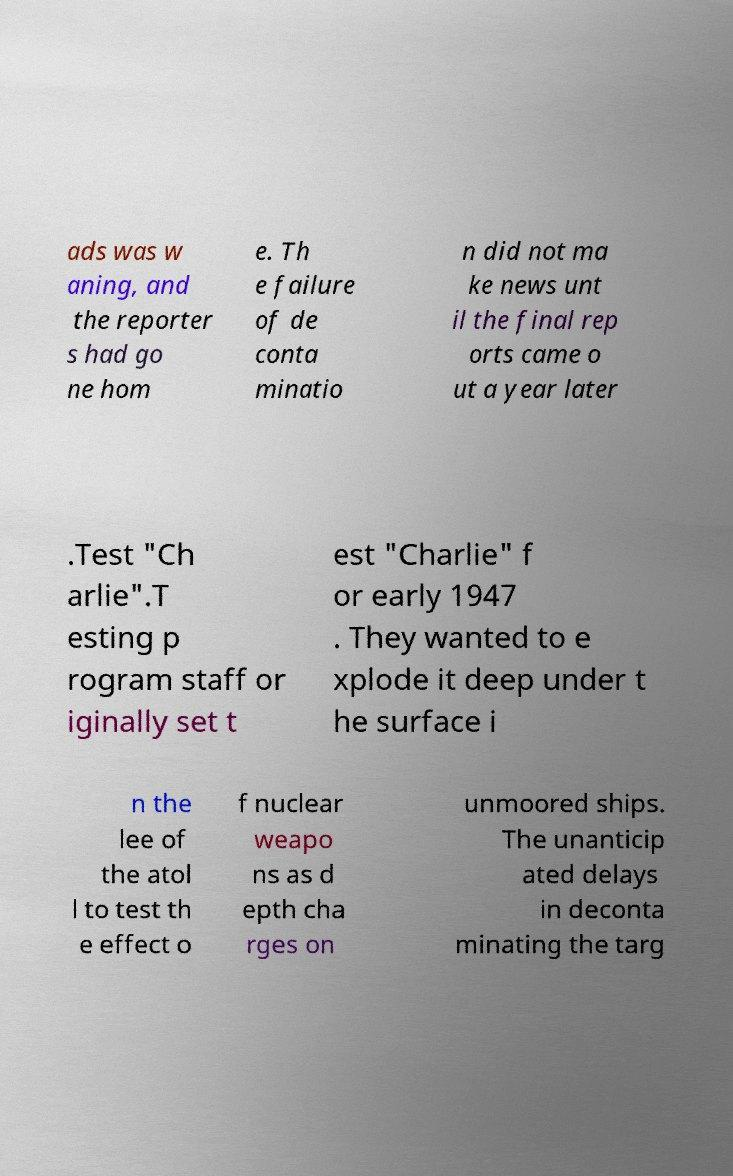I need the written content from this picture converted into text. Can you do that? ads was w aning, and the reporter s had go ne hom e. Th e failure of de conta minatio n did not ma ke news unt il the final rep orts came o ut a year later .Test "Ch arlie".T esting p rogram staff or iginally set t est "Charlie" f or early 1947 . They wanted to e xplode it deep under t he surface i n the lee of the atol l to test th e effect o f nuclear weapo ns as d epth cha rges on unmoored ships. The unanticip ated delays in deconta minating the targ 